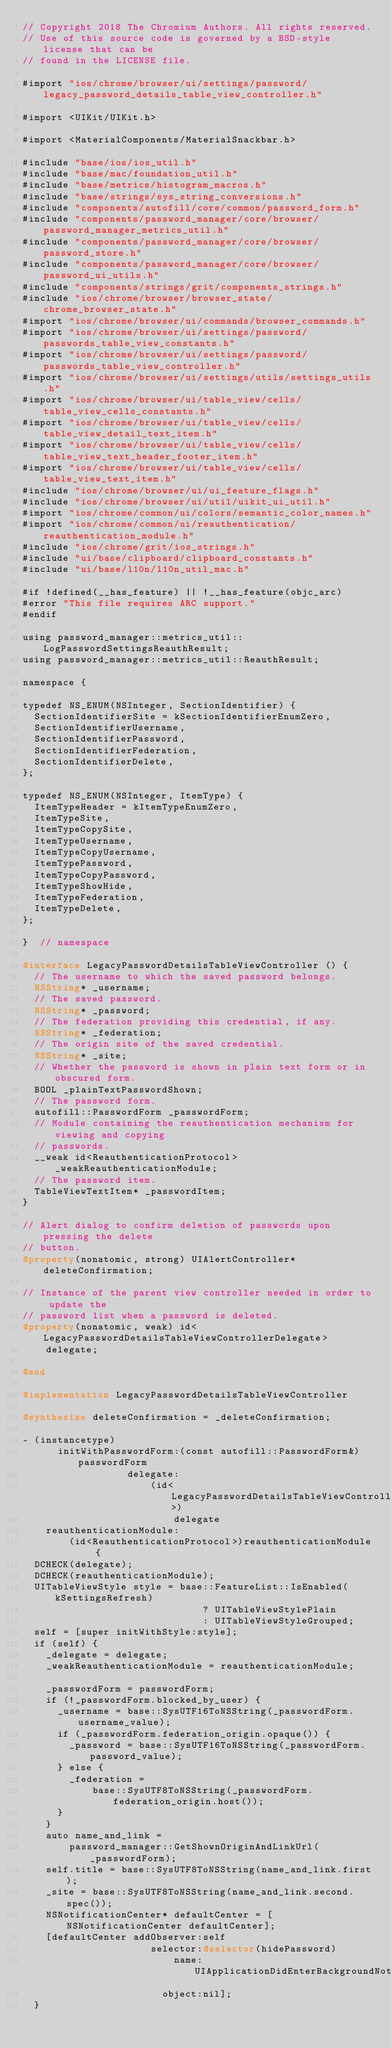<code> <loc_0><loc_0><loc_500><loc_500><_ObjectiveC_>// Copyright 2018 The Chromium Authors. All rights reserved.
// Use of this source code is governed by a BSD-style license that can be
// found in the LICENSE file.

#import "ios/chrome/browser/ui/settings/password/legacy_password_details_table_view_controller.h"

#import <UIKit/UIKit.h>

#import <MaterialComponents/MaterialSnackbar.h>

#include "base/ios/ios_util.h"
#include "base/mac/foundation_util.h"
#include "base/metrics/histogram_macros.h"
#include "base/strings/sys_string_conversions.h"
#include "components/autofill/core/common/password_form.h"
#include "components/password_manager/core/browser/password_manager_metrics_util.h"
#include "components/password_manager/core/browser/password_store.h"
#include "components/password_manager/core/browser/password_ui_utils.h"
#include "components/strings/grit/components_strings.h"
#include "ios/chrome/browser/browser_state/chrome_browser_state.h"
#import "ios/chrome/browser/ui/commands/browser_commands.h"
#import "ios/chrome/browser/ui/settings/password/passwords_table_view_constants.h"
#import "ios/chrome/browser/ui/settings/password/passwords_table_view_controller.h"
#import "ios/chrome/browser/ui/settings/utils/settings_utils.h"
#import "ios/chrome/browser/ui/table_view/cells/table_view_cells_constants.h"
#import "ios/chrome/browser/ui/table_view/cells/table_view_detail_text_item.h"
#import "ios/chrome/browser/ui/table_view/cells/table_view_text_header_footer_item.h"
#import "ios/chrome/browser/ui/table_view/cells/table_view_text_item.h"
#include "ios/chrome/browser/ui/ui_feature_flags.h"
#include "ios/chrome/browser/ui/util/uikit_ui_util.h"
#import "ios/chrome/common/ui/colors/semantic_color_names.h"
#import "ios/chrome/common/ui/reauthentication/reauthentication_module.h"
#include "ios/chrome/grit/ios_strings.h"
#include "ui/base/clipboard/clipboard_constants.h"
#include "ui/base/l10n/l10n_util_mac.h"

#if !defined(__has_feature) || !__has_feature(objc_arc)
#error "This file requires ARC support."
#endif

using password_manager::metrics_util::LogPasswordSettingsReauthResult;
using password_manager::metrics_util::ReauthResult;

namespace {

typedef NS_ENUM(NSInteger, SectionIdentifier) {
  SectionIdentifierSite = kSectionIdentifierEnumZero,
  SectionIdentifierUsername,
  SectionIdentifierPassword,
  SectionIdentifierFederation,
  SectionIdentifierDelete,
};

typedef NS_ENUM(NSInteger, ItemType) {
  ItemTypeHeader = kItemTypeEnumZero,
  ItemTypeSite,
  ItemTypeCopySite,
  ItemTypeUsername,
  ItemTypeCopyUsername,
  ItemTypePassword,
  ItemTypeCopyPassword,
  ItemTypeShowHide,
  ItemTypeFederation,
  ItemTypeDelete,
};

}  // namespace

@interface LegacyPasswordDetailsTableViewController () {
  // The username to which the saved password belongs.
  NSString* _username;
  // The saved password.
  NSString* _password;
  // The federation providing this credential, if any.
  NSString* _federation;
  // The origin site of the saved credential.
  NSString* _site;
  // Whether the password is shown in plain text form or in obscured form.
  BOOL _plainTextPasswordShown;
  // The password form.
  autofill::PasswordForm _passwordForm;
  // Module containing the reauthentication mechanism for viewing and copying
  // passwords.
  __weak id<ReauthenticationProtocol> _weakReauthenticationModule;
  // The password item.
  TableViewTextItem* _passwordItem;
}

// Alert dialog to confirm deletion of passwords upon pressing the delete
// button.
@property(nonatomic, strong) UIAlertController* deleteConfirmation;

// Instance of the parent view controller needed in order to update the
// password list when a password is deleted.
@property(nonatomic, weak) id<LegacyPasswordDetailsTableViewControllerDelegate>
    delegate;

@end

@implementation LegacyPasswordDetailsTableViewController

@synthesize deleteConfirmation = _deleteConfirmation;

- (instancetype)
      initWithPasswordForm:(const autofill::PasswordForm&)passwordForm
                  delegate:
                      (id<LegacyPasswordDetailsTableViewControllerDelegate>)
                          delegate
    reauthenticationModule:
        (id<ReauthenticationProtocol>)reauthenticationModule {
  DCHECK(delegate);
  DCHECK(reauthenticationModule);
  UITableViewStyle style = base::FeatureList::IsEnabled(kSettingsRefresh)
                               ? UITableViewStylePlain
                               : UITableViewStyleGrouped;
  self = [super initWithStyle:style];
  if (self) {
    _delegate = delegate;
    _weakReauthenticationModule = reauthenticationModule;

    _passwordForm = passwordForm;
    if (!_passwordForm.blocked_by_user) {
      _username = base::SysUTF16ToNSString(_passwordForm.username_value);
      if (_passwordForm.federation_origin.opaque()) {
        _password = base::SysUTF16ToNSString(_passwordForm.password_value);
      } else {
        _federation =
            base::SysUTF8ToNSString(_passwordForm.federation_origin.host());
      }
    }
    auto name_and_link =
        password_manager::GetShownOriginAndLinkUrl(_passwordForm);
    self.title = base::SysUTF8ToNSString(name_and_link.first);
    _site = base::SysUTF8ToNSString(name_and_link.second.spec());
    NSNotificationCenter* defaultCenter = [NSNotificationCenter defaultCenter];
    [defaultCenter addObserver:self
                      selector:@selector(hidePassword)
                          name:UIApplicationDidEnterBackgroundNotification
                        object:nil];
  }</code> 